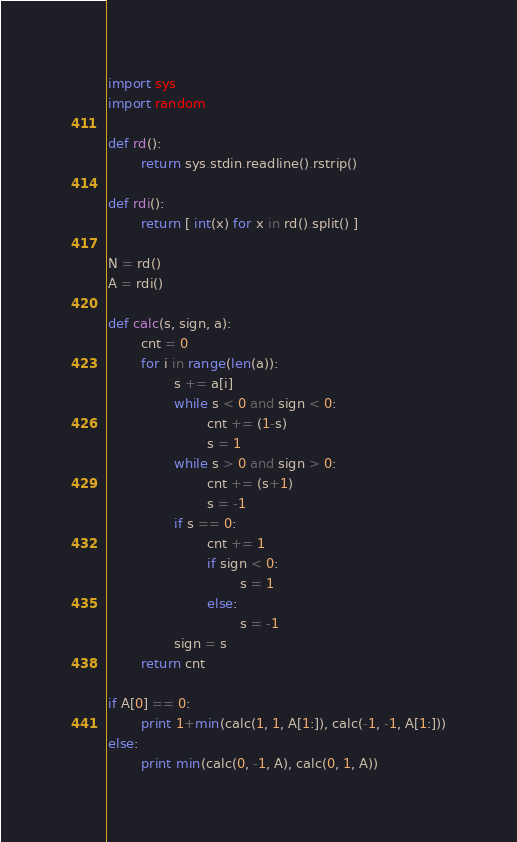Convert code to text. <code><loc_0><loc_0><loc_500><loc_500><_Python_>import sys
import random

def rd():
        return sys.stdin.readline().rstrip()

def rdi():
        return [ int(x) for x in rd().split() ]

N = rd()
A = rdi()

def calc(s, sign, a):
        cnt = 0
        for i in range(len(a)):
                s += a[i]
                while s < 0 and sign < 0:
                        cnt += (1-s)
                        s = 1
                while s > 0 and sign > 0:
                        cnt += (s+1)
                        s = -1
                if s == 0:
                        cnt += 1
                        if sign < 0:
                                s = 1
                        else:
                                s = -1
                sign = s
        return cnt

if A[0] == 0:
        print 1+min(calc(1, 1, A[1:]), calc(-1, -1, A[1:]))
else:
        print min(calc(0, -1, A), calc(0, 1, A))
</code> 